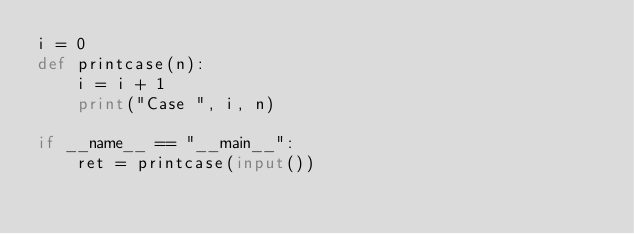Convert code to text. <code><loc_0><loc_0><loc_500><loc_500><_Python_>i = 0
def printcase(n):
    i = i + 1
    print("Case ", i, n)

if __name__ == "__main__":
    ret = printcase(input())
</code> 